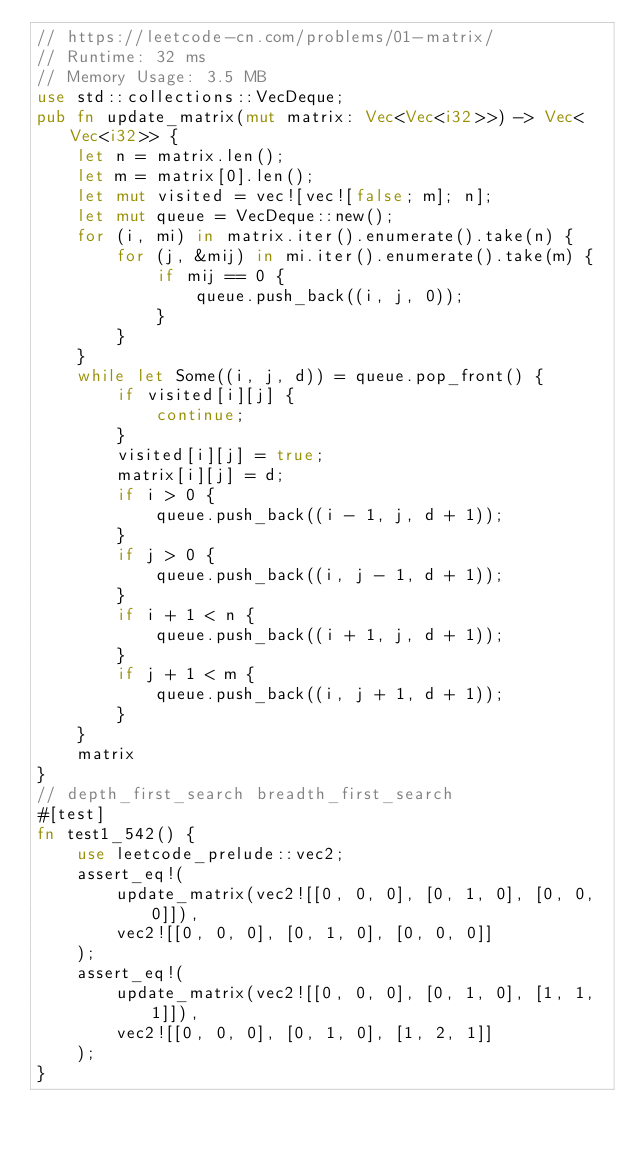Convert code to text. <code><loc_0><loc_0><loc_500><loc_500><_Rust_>// https://leetcode-cn.com/problems/01-matrix/
// Runtime: 32 ms
// Memory Usage: 3.5 MB
use std::collections::VecDeque;
pub fn update_matrix(mut matrix: Vec<Vec<i32>>) -> Vec<Vec<i32>> {
    let n = matrix.len();
    let m = matrix[0].len();
    let mut visited = vec![vec![false; m]; n];
    let mut queue = VecDeque::new();
    for (i, mi) in matrix.iter().enumerate().take(n) {
        for (j, &mij) in mi.iter().enumerate().take(m) {
            if mij == 0 {
                queue.push_back((i, j, 0));
            }
        }
    }
    while let Some((i, j, d)) = queue.pop_front() {
        if visited[i][j] {
            continue;
        }
        visited[i][j] = true;
        matrix[i][j] = d;
        if i > 0 {
            queue.push_back((i - 1, j, d + 1));
        }
        if j > 0 {
            queue.push_back((i, j - 1, d + 1));
        }
        if i + 1 < n {
            queue.push_back((i + 1, j, d + 1));
        }
        if j + 1 < m {
            queue.push_back((i, j + 1, d + 1));
        }
    }
    matrix
}
// depth_first_search breadth_first_search
#[test]
fn test1_542() {
    use leetcode_prelude::vec2;
    assert_eq!(
        update_matrix(vec2![[0, 0, 0], [0, 1, 0], [0, 0, 0]]),
        vec2![[0, 0, 0], [0, 1, 0], [0, 0, 0]]
    );
    assert_eq!(
        update_matrix(vec2![[0, 0, 0], [0, 1, 0], [1, 1, 1]]),
        vec2![[0, 0, 0], [0, 1, 0], [1, 2, 1]]
    );
}
</code> 